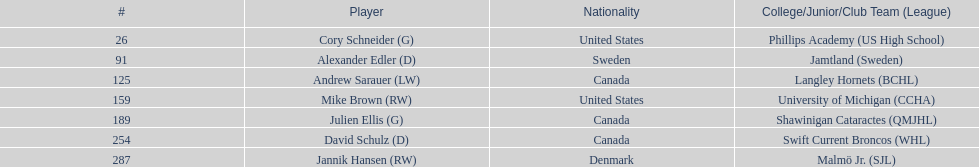How many goalies drafted? 2. 